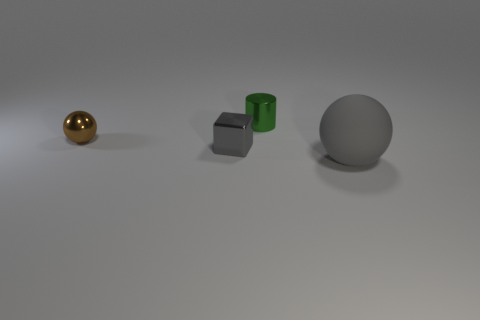Add 3 tiny yellow metal spheres. How many objects exist? 7 Subtract all cylinders. How many objects are left? 3 Add 2 metallic cubes. How many metallic cubes exist? 3 Subtract 0 cyan cylinders. How many objects are left? 4 Subtract all small green objects. Subtract all brown metal objects. How many objects are left? 2 Add 1 tiny metallic blocks. How many tiny metallic blocks are left? 2 